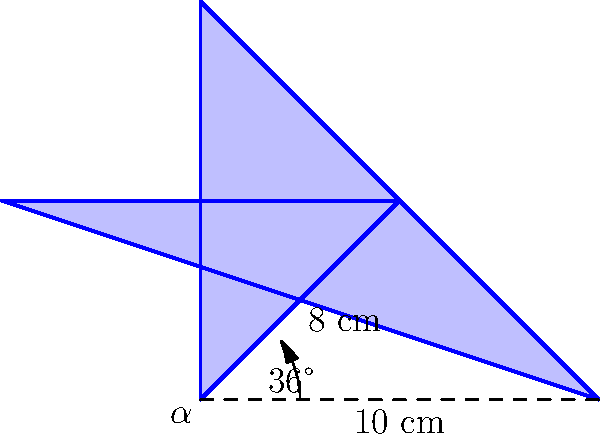A star-shaped award plaque for a best-selling author is designed as shown in the figure. The plaque has 5 identical points, with the distance between adjacent points being 10 cm. The length from the center to any point is 8 cm, and the angle between two adjacent points is 36°. Calculate the area of the plaque to the nearest square centimeter. To find the area of the star-shaped plaque, we'll follow these steps:

1) The star can be divided into 5 identical isosceles triangles.

2) Let's focus on one triangle:
   - Base = 10 cm
   - Height = 8 cm
   - Angle at the center = 36°

3) Area of one triangle:
   $$A_{triangle} = \frac{1}{2} \times base \times height$$
   $$A_{triangle} = \frac{1}{2} \times 10 \times 8 = 40 \text{ cm}^2$$

4) However, this includes extra area. We need to subtract the area of the small triangle at the base:

5) To find the height of the small triangle:
   $$\tan(18°) = \frac{h}{5}$$
   $$h = 5 \times \tan(18°) \approx 1.62 \text{ cm}$$

6) Area of small triangle:
   $$A_{small} = \frac{1}{2} \times 10 \times 1.62 = 8.1 \text{ cm}^2$$

7) Actual area of one point:
   $$A_{point} = 40 - 8.1 = 31.9 \text{ cm}^2$$

8) Total area of star:
   $$A_{total} = 5 \times 31.9 = 159.5 \text{ cm}^2$$

9) Rounding to the nearest square centimeter:
   $$A_{total} \approx 160 \text{ cm}^2$$
Answer: 160 cm² 